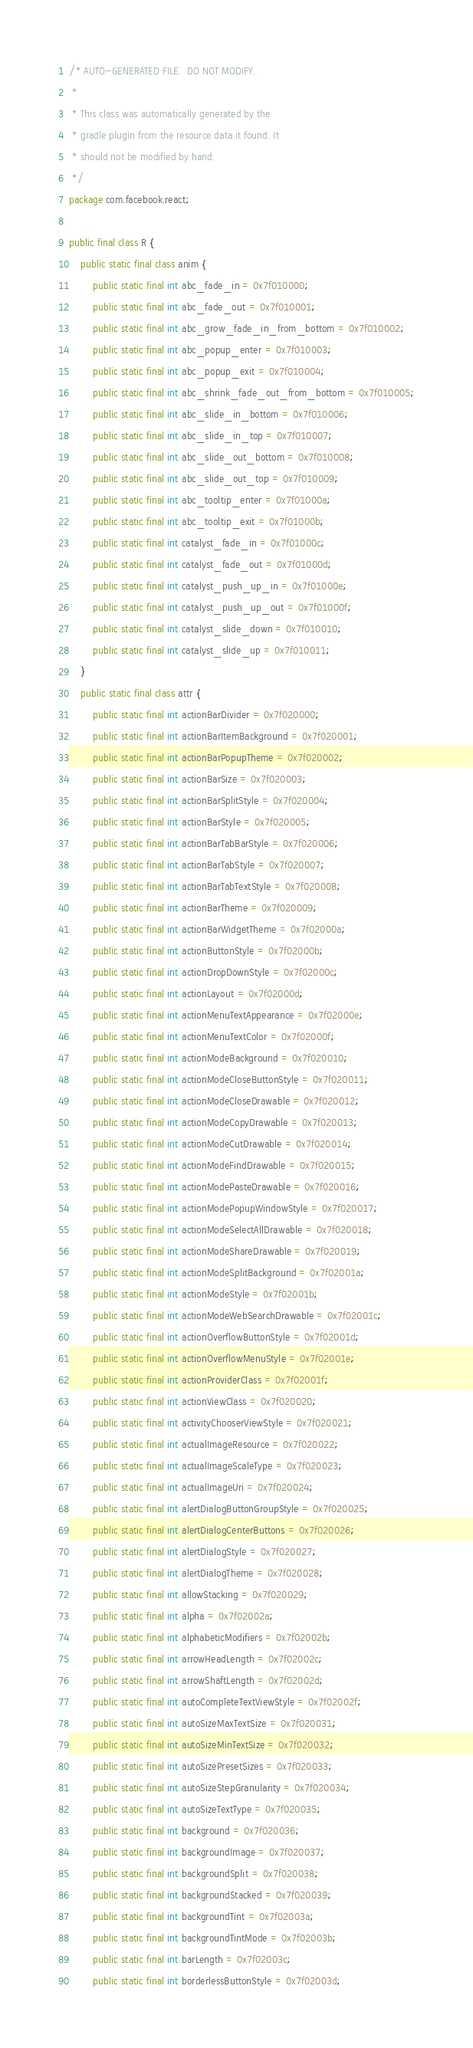Convert code to text. <code><loc_0><loc_0><loc_500><loc_500><_Java_>/* AUTO-GENERATED FILE.  DO NOT MODIFY.
 *
 * This class was automatically generated by the
 * gradle plugin from the resource data it found. It
 * should not be modified by hand.
 */
package com.facebook.react;

public final class R {
    public static final class anim {
        public static final int abc_fade_in = 0x7f010000;
        public static final int abc_fade_out = 0x7f010001;
        public static final int abc_grow_fade_in_from_bottom = 0x7f010002;
        public static final int abc_popup_enter = 0x7f010003;
        public static final int abc_popup_exit = 0x7f010004;
        public static final int abc_shrink_fade_out_from_bottom = 0x7f010005;
        public static final int abc_slide_in_bottom = 0x7f010006;
        public static final int abc_slide_in_top = 0x7f010007;
        public static final int abc_slide_out_bottom = 0x7f010008;
        public static final int abc_slide_out_top = 0x7f010009;
        public static final int abc_tooltip_enter = 0x7f01000a;
        public static final int abc_tooltip_exit = 0x7f01000b;
        public static final int catalyst_fade_in = 0x7f01000c;
        public static final int catalyst_fade_out = 0x7f01000d;
        public static final int catalyst_push_up_in = 0x7f01000e;
        public static final int catalyst_push_up_out = 0x7f01000f;
        public static final int catalyst_slide_down = 0x7f010010;
        public static final int catalyst_slide_up = 0x7f010011;
    }
    public static final class attr {
        public static final int actionBarDivider = 0x7f020000;
        public static final int actionBarItemBackground = 0x7f020001;
        public static final int actionBarPopupTheme = 0x7f020002;
        public static final int actionBarSize = 0x7f020003;
        public static final int actionBarSplitStyle = 0x7f020004;
        public static final int actionBarStyle = 0x7f020005;
        public static final int actionBarTabBarStyle = 0x7f020006;
        public static final int actionBarTabStyle = 0x7f020007;
        public static final int actionBarTabTextStyle = 0x7f020008;
        public static final int actionBarTheme = 0x7f020009;
        public static final int actionBarWidgetTheme = 0x7f02000a;
        public static final int actionButtonStyle = 0x7f02000b;
        public static final int actionDropDownStyle = 0x7f02000c;
        public static final int actionLayout = 0x7f02000d;
        public static final int actionMenuTextAppearance = 0x7f02000e;
        public static final int actionMenuTextColor = 0x7f02000f;
        public static final int actionModeBackground = 0x7f020010;
        public static final int actionModeCloseButtonStyle = 0x7f020011;
        public static final int actionModeCloseDrawable = 0x7f020012;
        public static final int actionModeCopyDrawable = 0x7f020013;
        public static final int actionModeCutDrawable = 0x7f020014;
        public static final int actionModeFindDrawable = 0x7f020015;
        public static final int actionModePasteDrawable = 0x7f020016;
        public static final int actionModePopupWindowStyle = 0x7f020017;
        public static final int actionModeSelectAllDrawable = 0x7f020018;
        public static final int actionModeShareDrawable = 0x7f020019;
        public static final int actionModeSplitBackground = 0x7f02001a;
        public static final int actionModeStyle = 0x7f02001b;
        public static final int actionModeWebSearchDrawable = 0x7f02001c;
        public static final int actionOverflowButtonStyle = 0x7f02001d;
        public static final int actionOverflowMenuStyle = 0x7f02001e;
        public static final int actionProviderClass = 0x7f02001f;
        public static final int actionViewClass = 0x7f020020;
        public static final int activityChooserViewStyle = 0x7f020021;
        public static final int actualImageResource = 0x7f020022;
        public static final int actualImageScaleType = 0x7f020023;
        public static final int actualImageUri = 0x7f020024;
        public static final int alertDialogButtonGroupStyle = 0x7f020025;
        public static final int alertDialogCenterButtons = 0x7f020026;
        public static final int alertDialogStyle = 0x7f020027;
        public static final int alertDialogTheme = 0x7f020028;
        public static final int allowStacking = 0x7f020029;
        public static final int alpha = 0x7f02002a;
        public static final int alphabeticModifiers = 0x7f02002b;
        public static final int arrowHeadLength = 0x7f02002c;
        public static final int arrowShaftLength = 0x7f02002d;
        public static final int autoCompleteTextViewStyle = 0x7f02002f;
        public static final int autoSizeMaxTextSize = 0x7f020031;
        public static final int autoSizeMinTextSize = 0x7f020032;
        public static final int autoSizePresetSizes = 0x7f020033;
        public static final int autoSizeStepGranularity = 0x7f020034;
        public static final int autoSizeTextType = 0x7f020035;
        public static final int background = 0x7f020036;
        public static final int backgroundImage = 0x7f020037;
        public static final int backgroundSplit = 0x7f020038;
        public static final int backgroundStacked = 0x7f020039;
        public static final int backgroundTint = 0x7f02003a;
        public static final int backgroundTintMode = 0x7f02003b;
        public static final int barLength = 0x7f02003c;
        public static final int borderlessButtonStyle = 0x7f02003d;</code> 